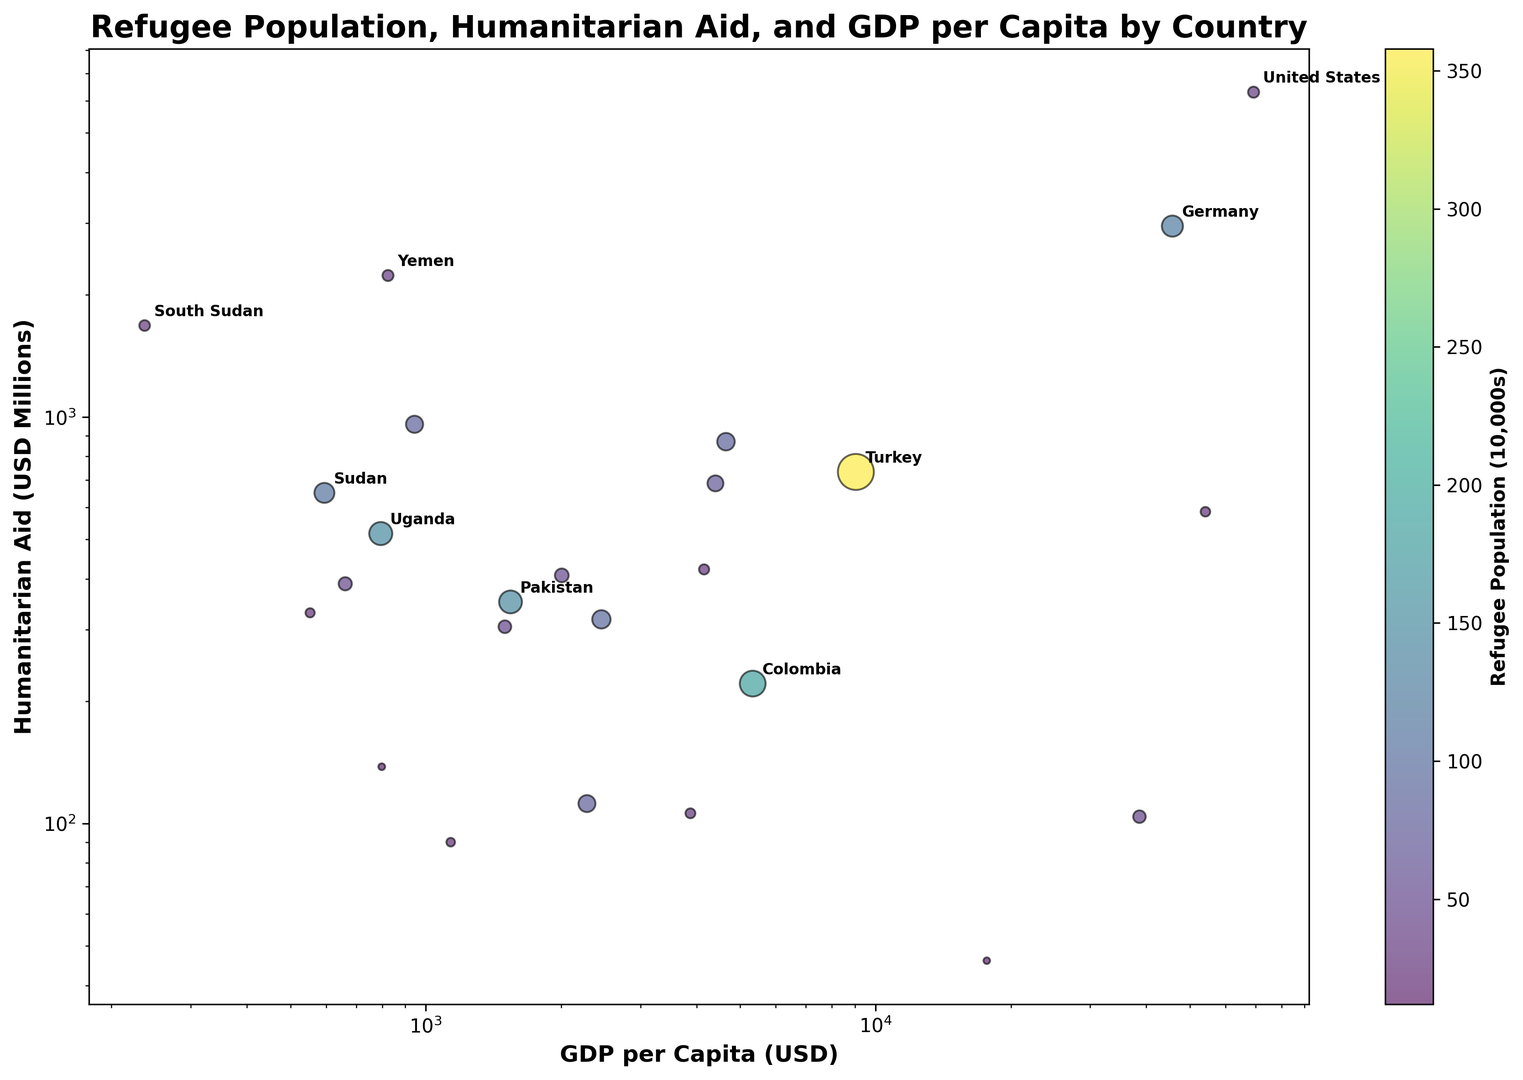What country has the highest amount of humanitarian aid? To find this, look at the y-axis which represents humanitarian aid in USD millions. Identify the country corresponding to the highest point on this axis, which is annotated.
Answer: United States Which country with a refugee population over 1,000,000 has the highest GDP per capita? Filter visually based on bubble size indicating refugee population > 1,000,000. Then compare x-axis positions (GDP per capita) of these countries.
Answer: Germany What is the total refugee population of the countries that receive more than 1000 million USD in humanitarian aid? Identify countries with aid > 1000 million (Yemen, United States, South Sudan). Sum their refugee populations from the annotated bubbles.
Answer: 3,376,887 Which country has a larger refugee population, Jordan or Chad? Locate Jordan and Chad on the chart. Compare the bubble sizes directly.
Answer: Jordan Compare the GDP per capita between Greece and Colombia. Which one is higher? Locate Greece and Colombia on the chart. Compare their x-axis positions (GDP per capita).
Answer: Greece How does the humanitarian aid received by Uganda compare to that received by Sudan? Find Uganda and Sudan. Compare their positions on the y-axis (humanitarian aid).
Answer: Uganda is less than Sudan Is there a strong correlation between GDP per capita and refugee population? Observe the trend or pattern of bubble sizes across the x-axis (GDP per capita). If no clear pattern, the correlation is weak.
Answer: No Which countries fall in the lower left quadrant of the graph, indicating low GDP per capita and low humanitarian aid? Identify the lower-left part of the chart (low x and y values). Note the annotated countries in this area.
Answer: Tanzania, Chad, Rwanda Does Pakistan receive more or less humanitarian aid than Bangladesh? Find both countries on the chart. Compare their positions on the y-axis (humanitarian aid).
Answer: More What is the common characteristic of countries in the upper right quadrant? Identify the upper right quadrant. The countries in this area have high GDP per capita and high humanitarian aid. Note the countries.
Answer: Wealthy countries with high aid (like the United States, Germany, Sweden) 